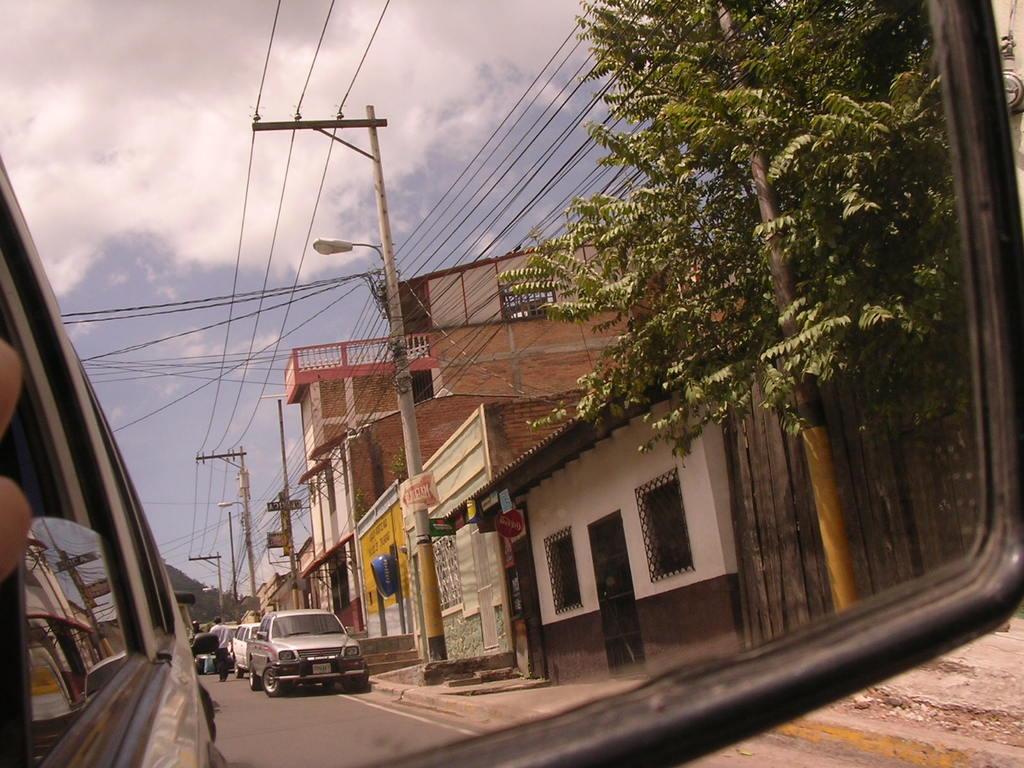In one or two sentences, can you explain what this image depicts? In this picture we can see a person and vehicles on the road, buildings with windows, trees, wires, poles and in the background we can see the sky with clouds. 